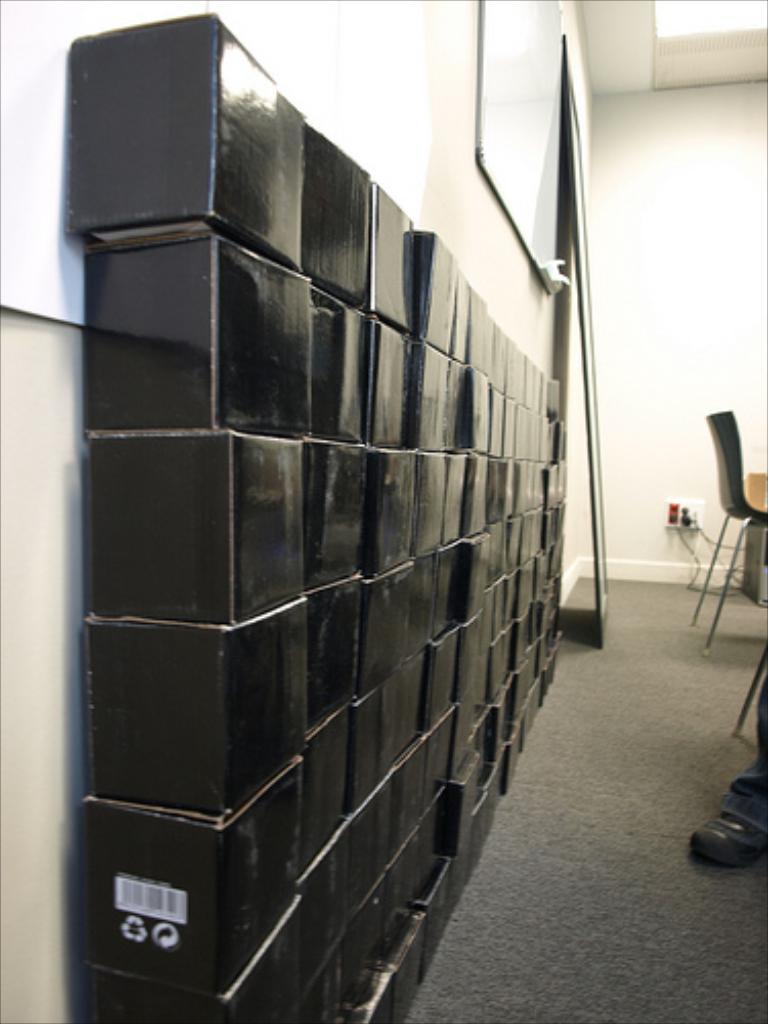Please provide a concise description of this image. On the left side, there are black color boxes arranged on the floor. Beside them, there are two white color boards attached to a wall and there is another board leaning on the wall. On the right side, there is a person wearing a shoe, there is a chair arranged and there is a device connected to a plug which is attached to a wall. 